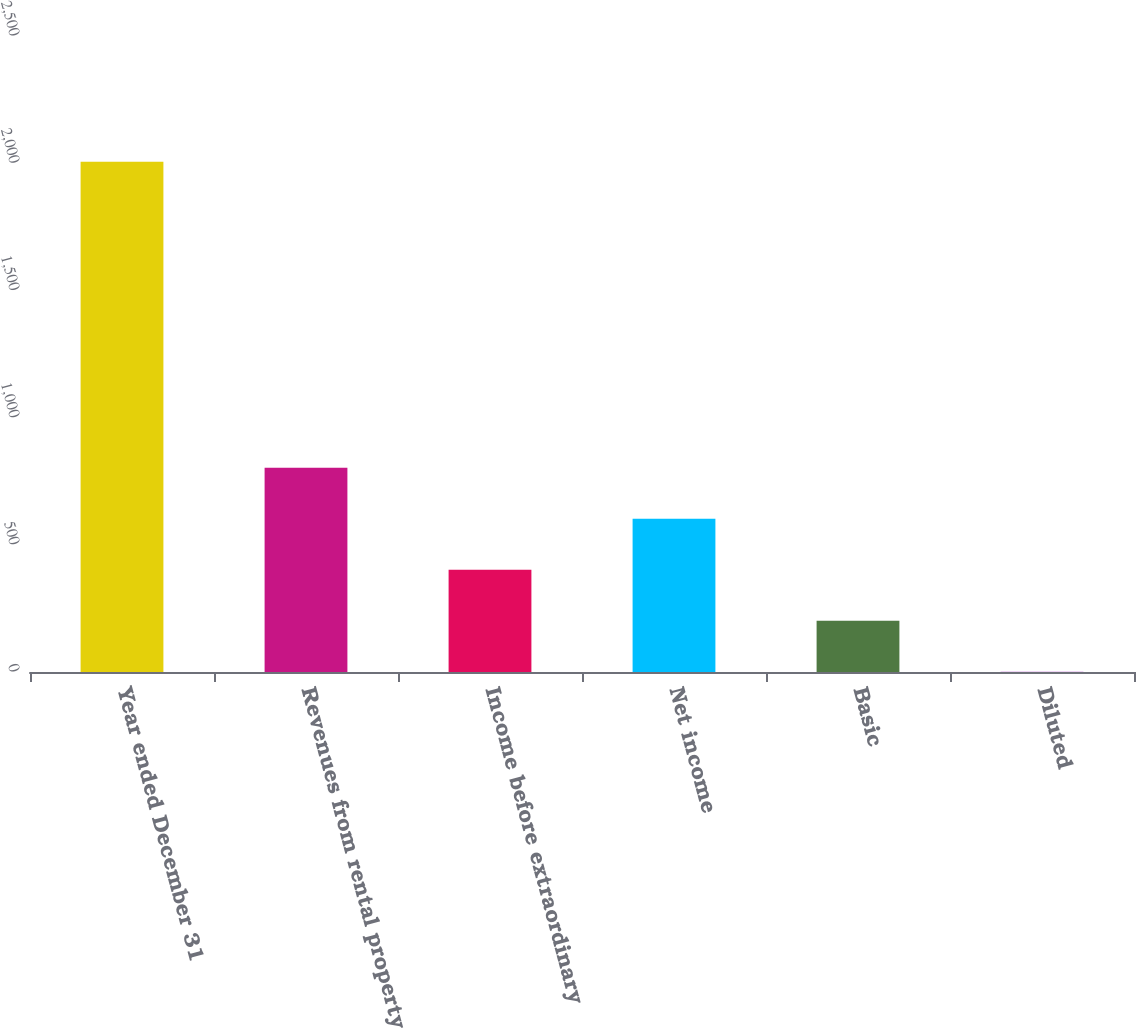Convert chart. <chart><loc_0><loc_0><loc_500><loc_500><bar_chart><fcel>Year ended December 31<fcel>Revenues from rental property<fcel>Income before extraordinary<fcel>Net income<fcel>Basic<fcel>Diluted<nl><fcel>2006<fcel>803.15<fcel>402.21<fcel>602.68<fcel>201.74<fcel>1.27<nl></chart> 